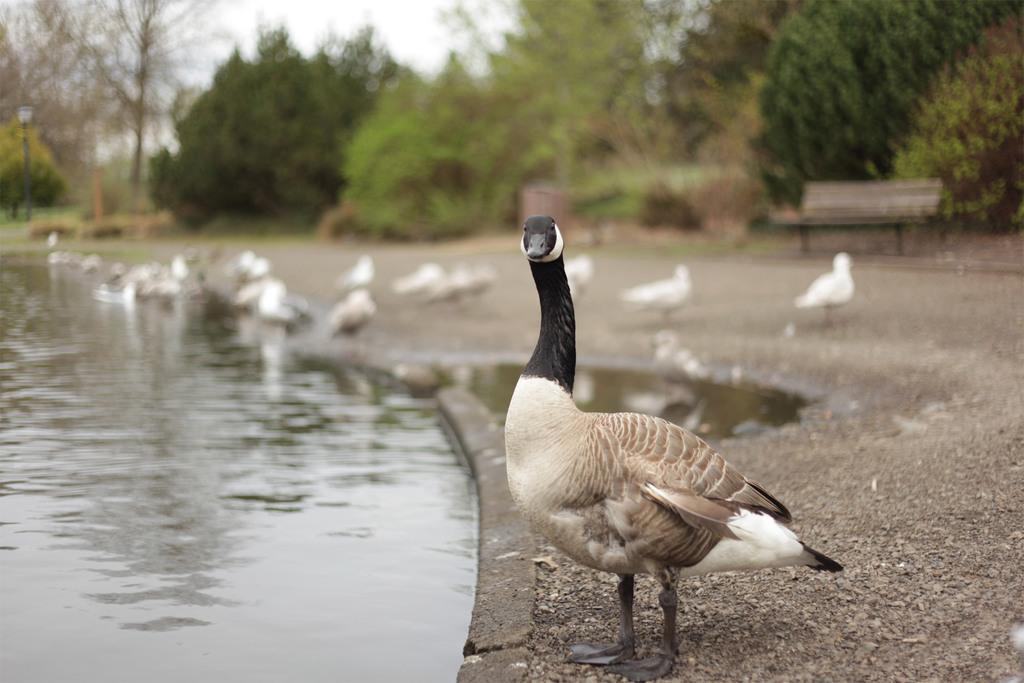Can you describe this image briefly? This is a duck standing. This looks like a pond with the water flowing. In the background, I can see few ducks. This is the bench. These are the trees. 